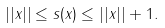Convert formula to latex. <formula><loc_0><loc_0><loc_500><loc_500>| | x | | \leq s ( x ) \leq | | x | | + 1 .</formula> 